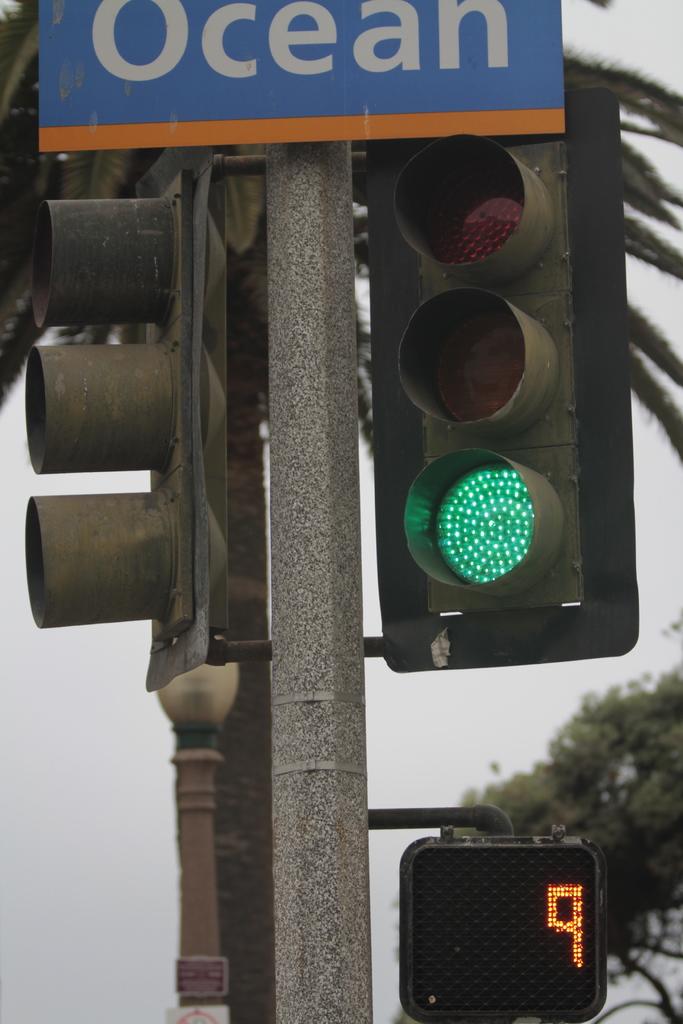Do you think if there are no pedestrians cars will still wait?
Make the answer very short. Unanswerable. 